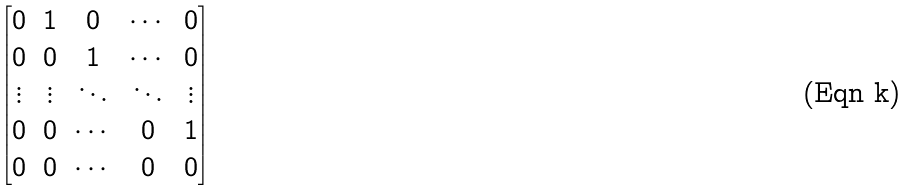Convert formula to latex. <formula><loc_0><loc_0><loc_500><loc_500>\begin{bmatrix} 0 & 1 & 0 & \cdots & 0 \\ 0 & 0 & 1 & \cdots & 0 \\ \vdots & \vdots & \ddots & \ddots & \vdots \\ 0 & 0 & \cdots & 0 & 1 \\ 0 & 0 & \cdots & 0 & 0 \end{bmatrix}</formula> 